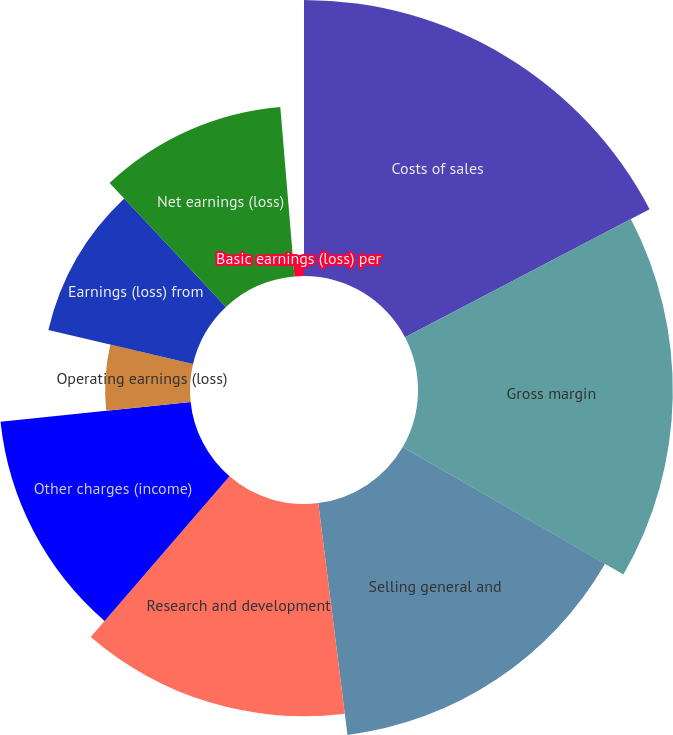<chart> <loc_0><loc_0><loc_500><loc_500><pie_chart><fcel>Costs of sales<fcel>Gross margin<fcel>Selling general and<fcel>Research and development<fcel>Other charges (income)<fcel>Operating earnings (loss)<fcel>Earnings (loss) from<fcel>Net earnings (loss)<fcel>Diluted earnings (loss) per<fcel>Basic earnings (loss) per<nl><fcel>17.33%<fcel>16.0%<fcel>14.67%<fcel>13.33%<fcel>12.0%<fcel>5.33%<fcel>9.33%<fcel>10.67%<fcel>0.0%<fcel>1.33%<nl></chart> 